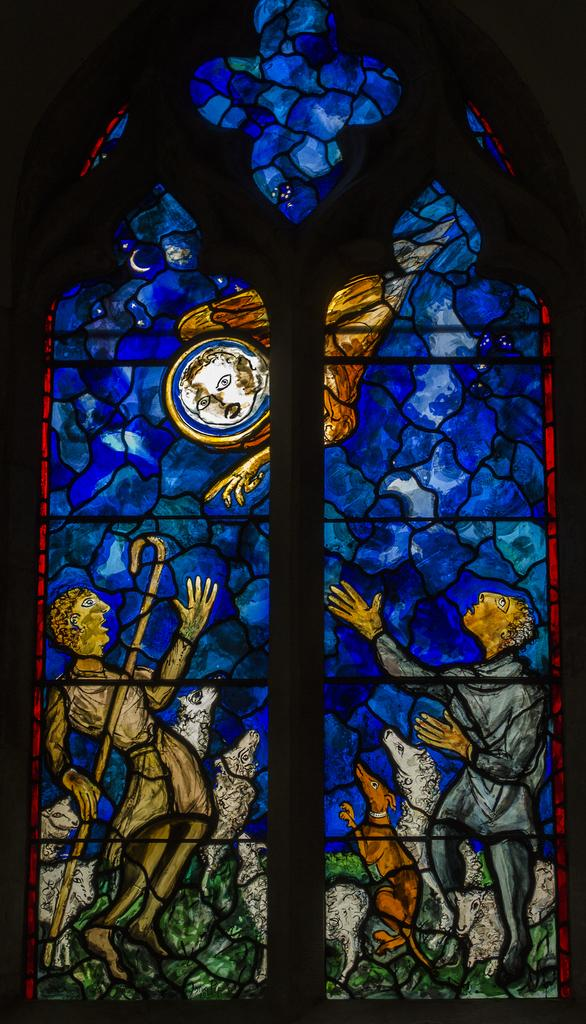What type of object is depicted in the image? There is a painted glass window in the image. Can you describe the appearance of the painted glass window? Unfortunately, the appearance of the painted glass window cannot be described in detail without more information. What might be the purpose of the painted glass window? The painted glass window might serve a decorative or artistic purpose, or it could be part of a larger architectural design. How does the crowd interact with the salt in the image? There is no crowd or salt present in the image; it only features a painted glass window. 